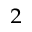Convert formula to latex. <formula><loc_0><loc_0><loc_500><loc_500>^ { 2 }</formula> 